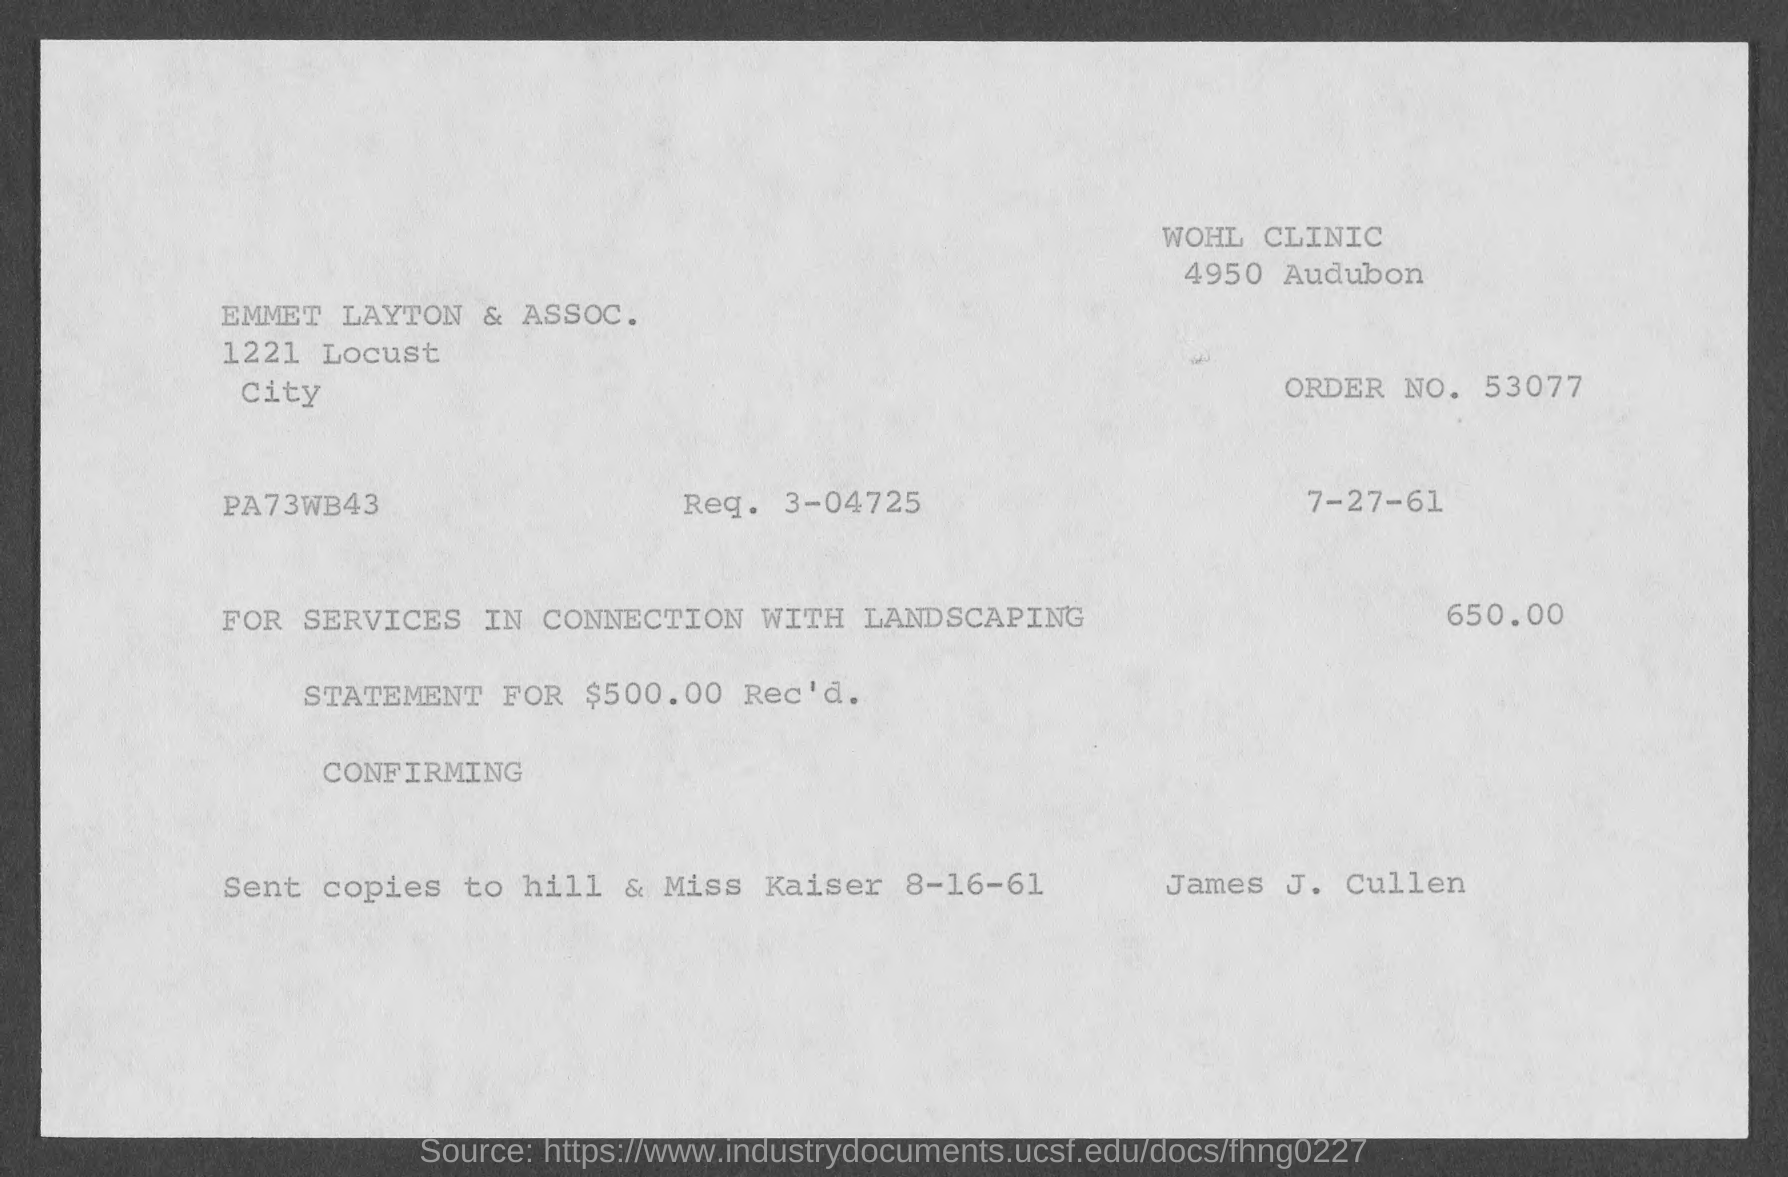Highlight a few significant elements in this photo. The requisition number specified in the invoice is 3-04725. The invoice is being raised by Emmett Layton & Associates. The issued date of the invoice is 7-27-61. The invoice amount mentioned in the document is 650.00. The order number provided in the invoice is 53077. 